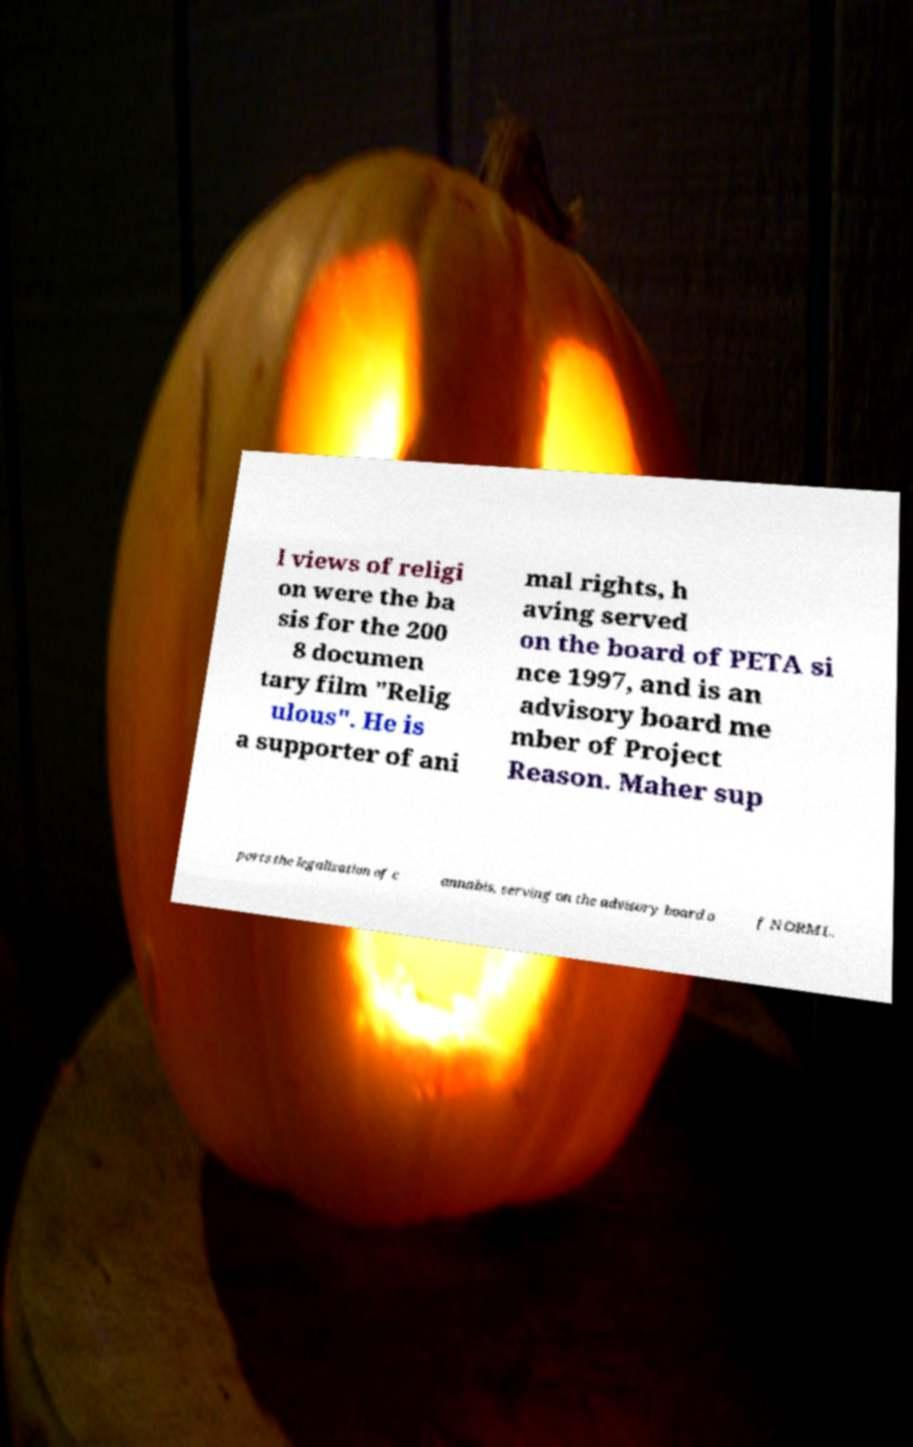Could you assist in decoding the text presented in this image and type it out clearly? l views of religi on were the ba sis for the 200 8 documen tary film "Relig ulous". He is a supporter of ani mal rights, h aving served on the board of PETA si nce 1997, and is an advisory board me mber of Project Reason. Maher sup ports the legalization of c annabis, serving on the advisory board o f NORML. 